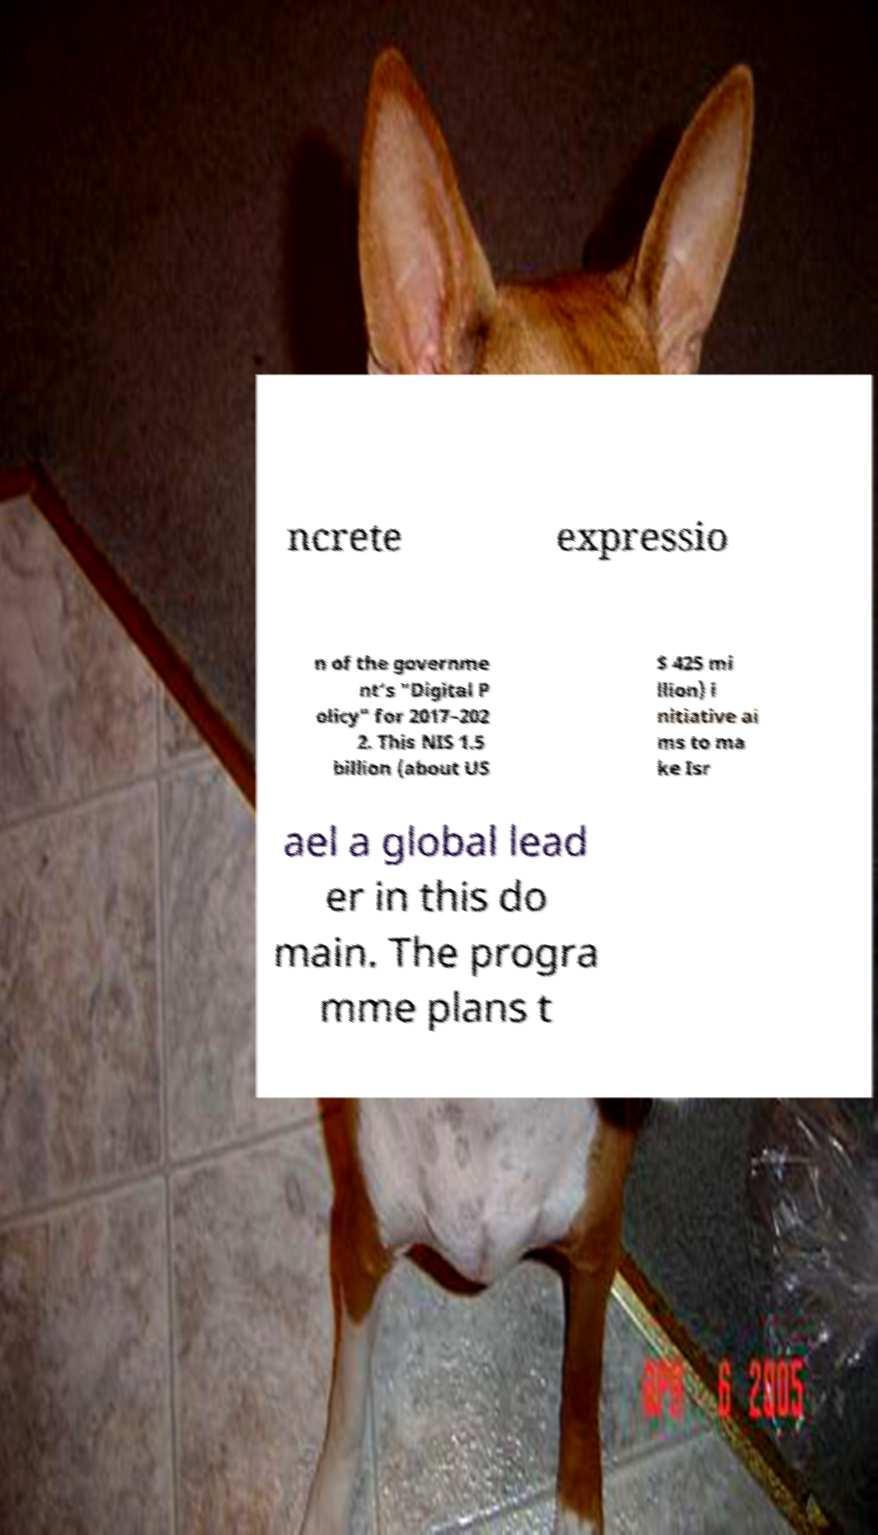Please identify and transcribe the text found in this image. ncrete expressio n of the governme nt’s "Digital P olicy" for 2017–202 2. This NIS 1.5 billion (about US $ 425 mi llion) i nitiative ai ms to ma ke Isr ael a global lead er in this do main. The progra mme plans t 